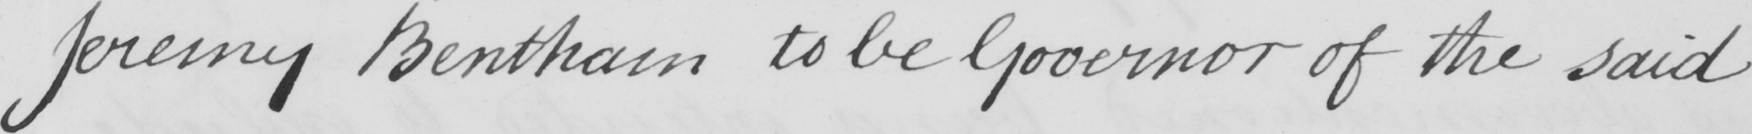Please transcribe the handwritten text in this image. Jeremy Bentham to be Governor of the said 